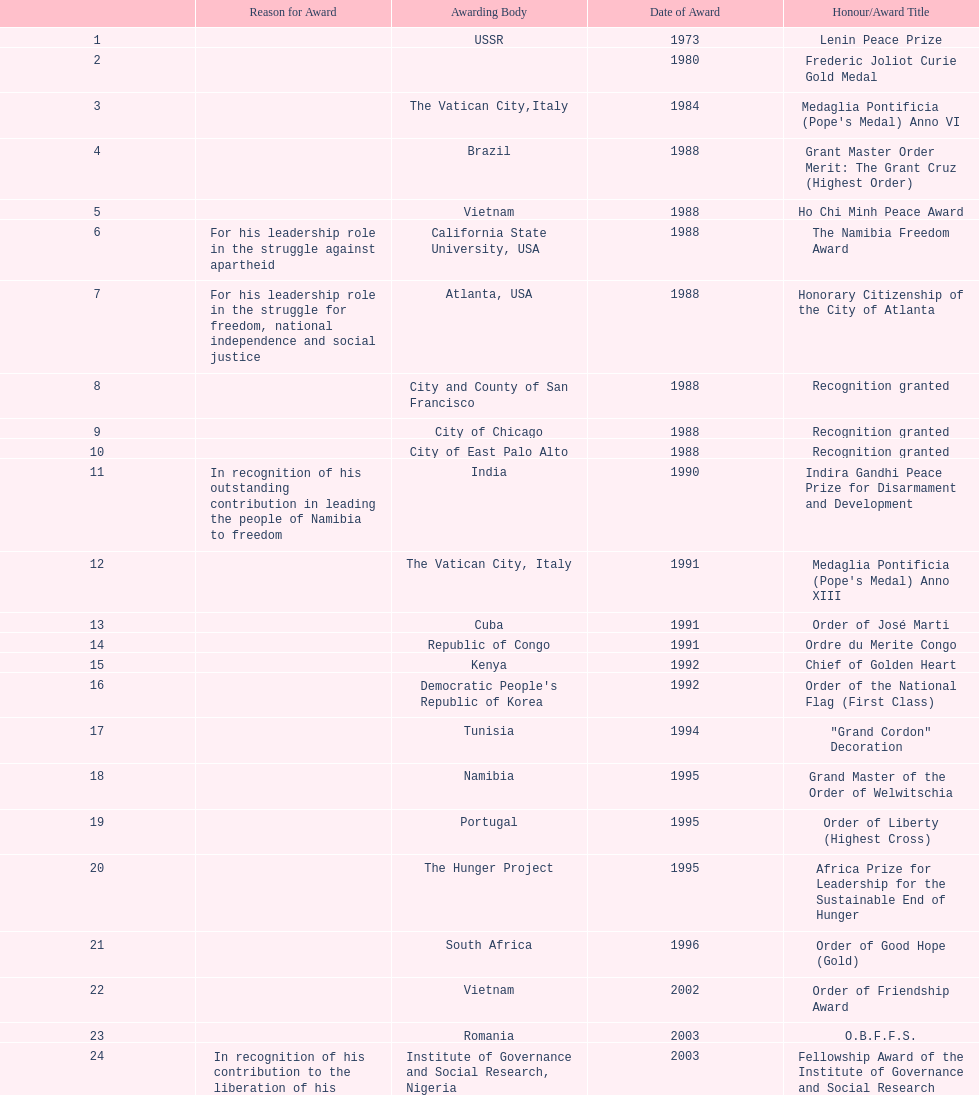What is the total number of awards that nujoma won? 29. 